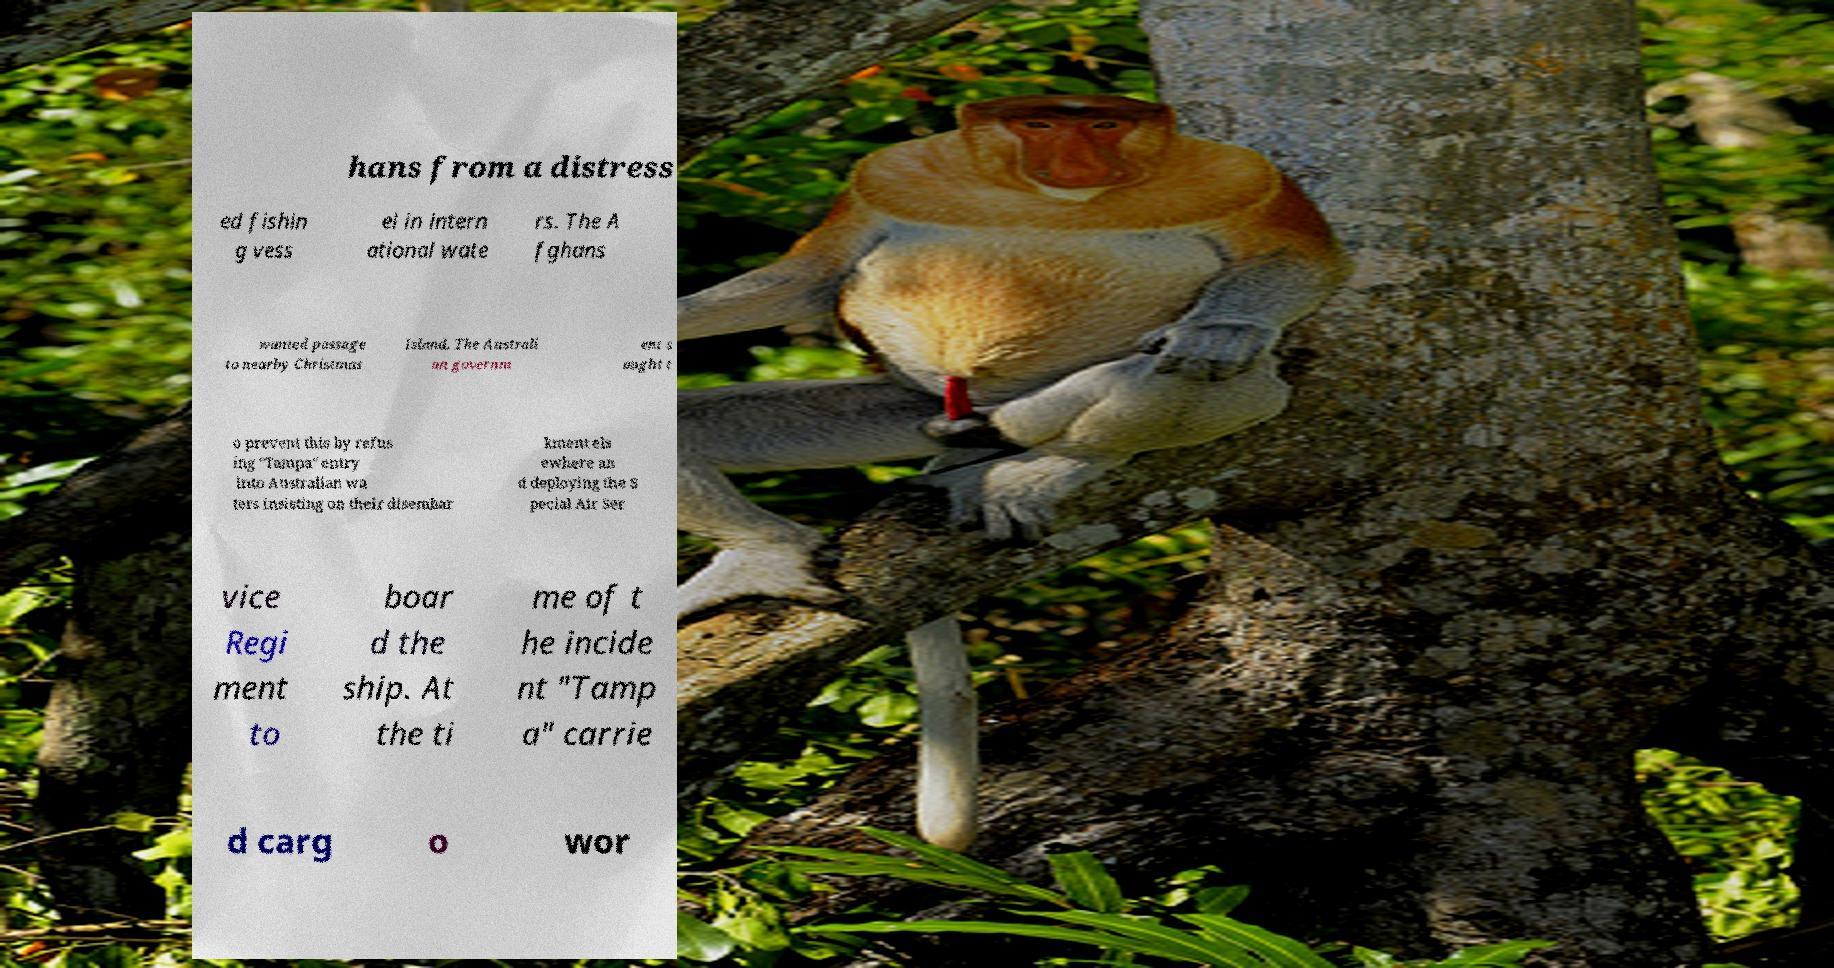Could you assist in decoding the text presented in this image and type it out clearly? hans from a distress ed fishin g vess el in intern ational wate rs. The A fghans wanted passage to nearby Christmas Island. The Australi an governm ent s ought t o prevent this by refus ing "Tampa" entry into Australian wa ters insisting on their disembar kment els ewhere an d deploying the S pecial Air Ser vice Regi ment to boar d the ship. At the ti me of t he incide nt "Tamp a" carrie d carg o wor 